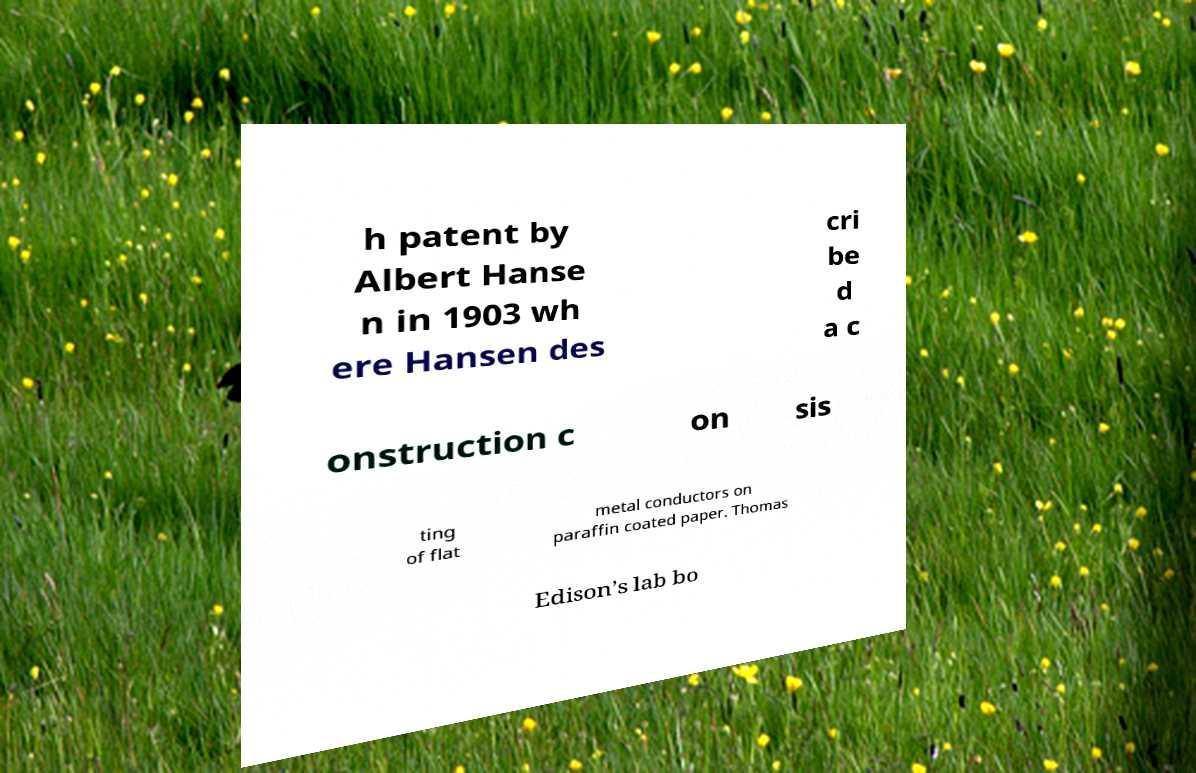Could you assist in decoding the text presented in this image and type it out clearly? h patent by Albert Hanse n in 1903 wh ere Hansen des cri be d a c onstruction c on sis ting of flat metal conductors on paraffin coated paper. Thomas Edison’s lab bo 